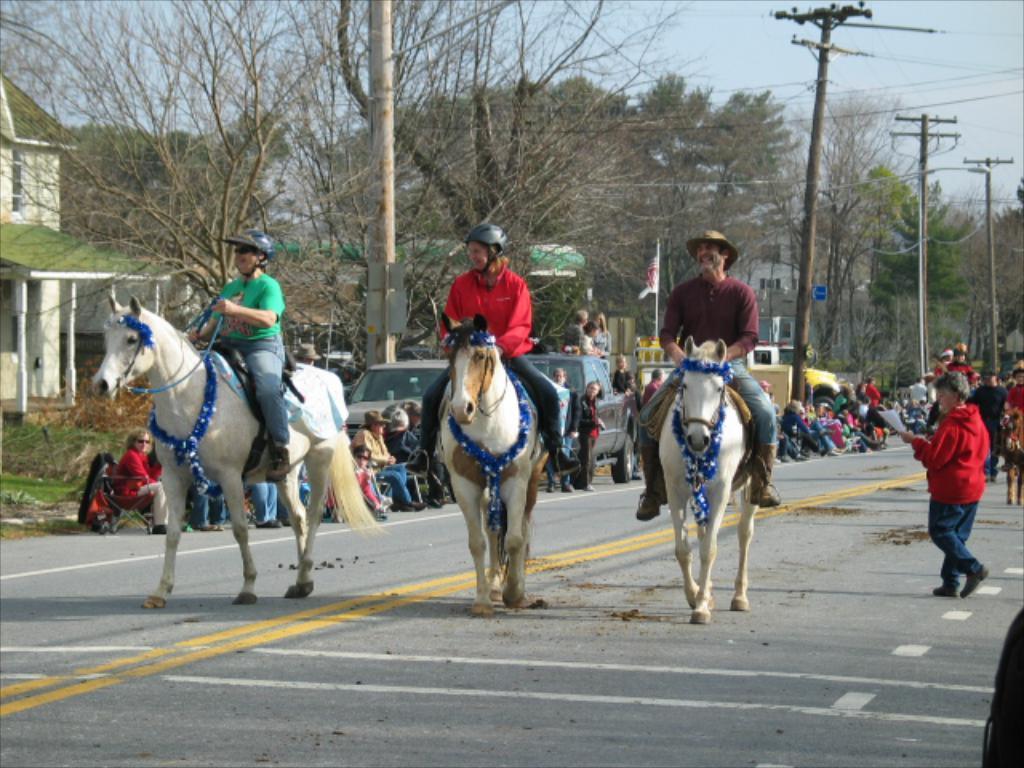Can you describe this image briefly? In this image we can see these people wearing helmets and shoes sitting on the horse and riding on the road. Here we can see a more people sitting on the road, we can see current poles, wires, trees, houses, vehicles parked here, flag and sky in the background. 